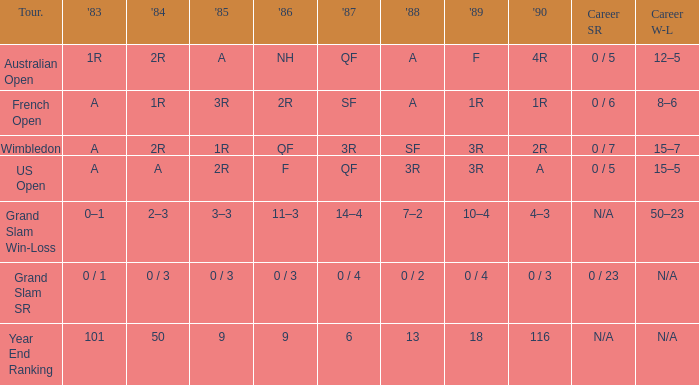What is the 1987 results when the results of 1989 is 3R, and the 1986 results is F? QF. 